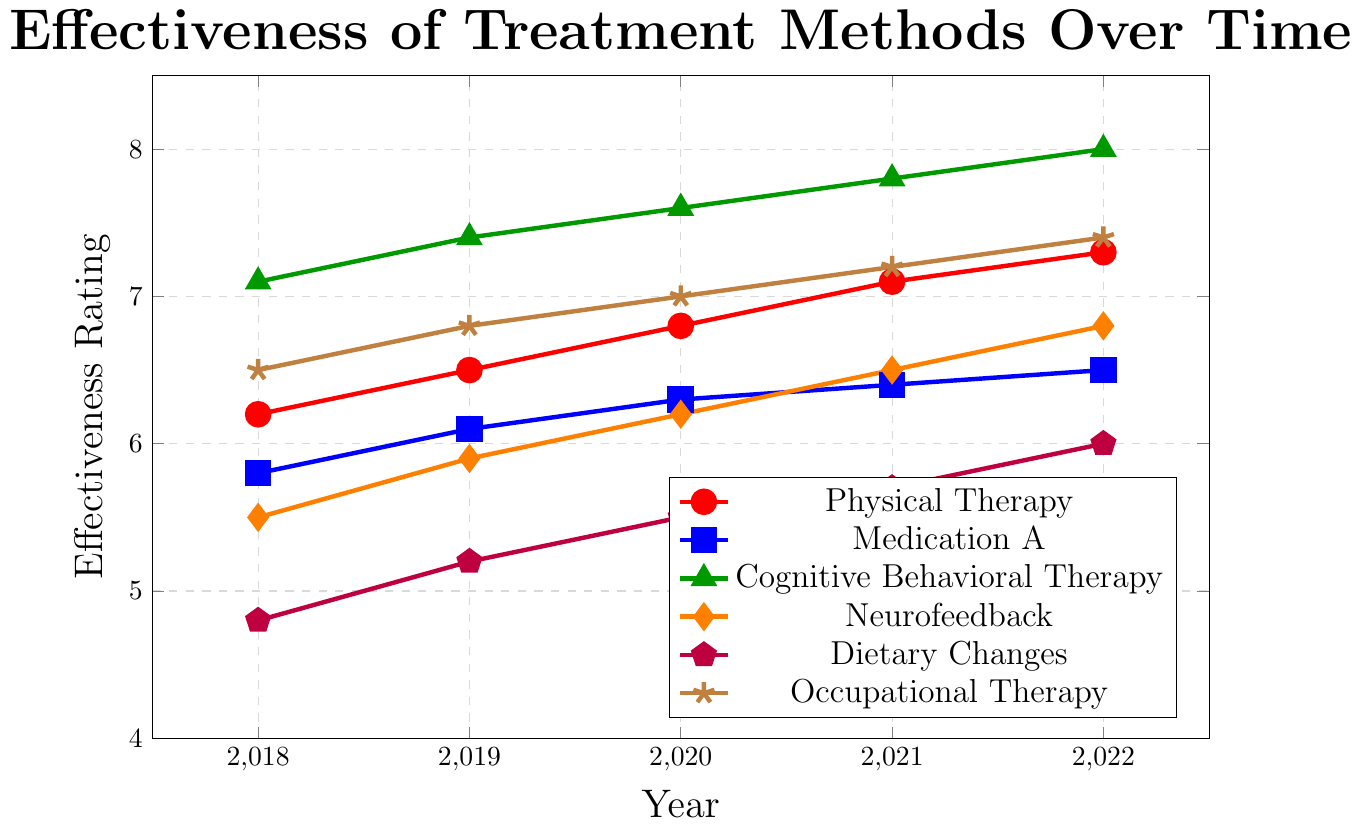What treatment method shows the highest effectiveness rating in 2022? Look for the treatment method with the highest point on the y-axis in 2022. Cognitive Behavioral Therapy has the highest point at 8.0.
Answer: Cognitive Behavioral Therapy Which treatment method shows the most improvement in effectiveness rating from 2018 to 2022? Calculate the difference in effectiveness ratings from 2018 to 2022 for each treatment method. Cognitive Behavioral Therapy improves from 7.1 to 8.0, a difference of 0.9, the highest among the treatment methods.
Answer: Cognitive Behavioral Therapy Which treatment method has the lowest starting effectiveness rating in 2018? Identify the treatment method with the lowest effectiveness rating in 2018. Dietary Changes begins at 4.8, which is the lowest.
Answer: Dietary Changes For which treatment method do the effectiveness ratings increase by the same amount each year? Examine the yearly increase for each treatment method. Physical Therapy, for example, increases by 0.3 each year.
Answer: Physical Therapy Compare the overall trend of effectiveness ratings for Neurofeedback and Medication A. Which one shows a steeper increase over the years? Calculate the total increase in effectiveness rating from 2018 to 2022 for both methods. Neurofeedback increases from 5.5 to 6.8 (1.3 increase) while Medication A increases from 5.8 to 6.5 (0.7 increase). Neurofeedback shows a steeper increase.
Answer: Neurofeedback What is the difference in effectiveness rating between Physical Therapy and Occupational Therapy in 2022? Subtract the effectiveness rating of Occupational Therapy from that of Physical Therapy in 2022. This is 7.3 - 7.4 = -0.1.
Answer: -0.1 List the treatments that have an effectiveness rating above 7.0 in the year 2022. Identify the treatments with data points above 7.0 for the year 2022. Cognitive Behavioral Therapy (8.0), Physical Therapy (7.3), and Occupational Therapy (7.4) meet the criteria.
Answer: Cognitive Behavioral Therapy, Physical Therapy, Occupational Therapy Which treatment method had the smallest effectiveness rating increase from 2018 to 2022? Find the treatment with the smallest difference in effectiveness ratings between 2018 and 2022. Medication A increased from 5.8 to 6.5, a difference of 0.7, which is the smallest.
Answer: Medication A What is the average effectiveness rating of Cognitive Behavioral Therapy over the 5-year period? Sum the yearly ratings for Cognitive Behavioral Therapy from 2018 to 2022 and divide by 5. (7.1 + 7.4 + 7.6 + 7.8 + 8.0)/5 = 38.1/5 = 7.62
Answer: 7.62 How does the effectiveness rating of Dietary Changes in 2022 compare to that of Neurofeedback in 2019? Compare the y-values for Dietary Changes in 2022 (6.0) and Neurofeedback in 2019 (5.9). 6.0 is greater than 5.9.
Answer: Dietary Changes in 2022 is higher 